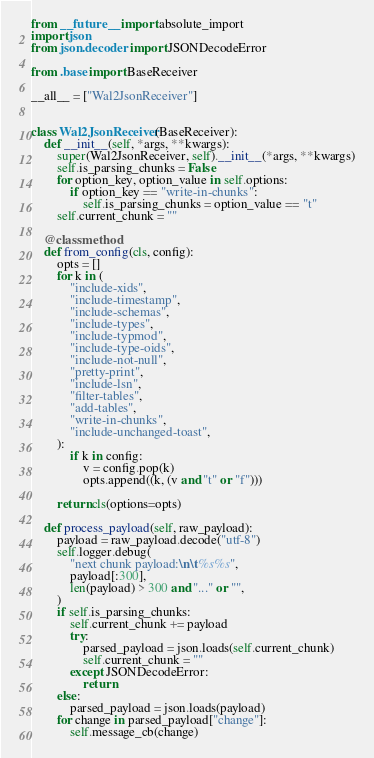Convert code to text. <code><loc_0><loc_0><loc_500><loc_500><_Python_>from __future__ import absolute_import
import json
from json.decoder import JSONDecodeError

from .base import BaseReceiver

__all__ = ["Wal2JsonReceiver"]


class Wal2JsonReceiver(BaseReceiver):
    def __init__(self, *args, **kwargs):
        super(Wal2JsonReceiver, self).__init__(*args, **kwargs)
        self.is_parsing_chunks = False
        for option_key, option_value in self.options:
            if option_key == "write-in-chunks":
                self.is_parsing_chunks = option_value == "t"
        self.current_chunk = ""

    @classmethod
    def from_config(cls, config):
        opts = []
        for k in (
            "include-xids",
            "include-timestamp",
            "include-schemas",
            "include-types",
            "include-typmod",
            "include-type-oids",
            "include-not-null",
            "pretty-print",
            "include-lsn",
            "filter-tables",
            "add-tables",
            "write-in-chunks",
            "include-unchanged-toast",
        ):
            if k in config:
                v = config.pop(k)
                opts.append((k, (v and "t" or "f")))

        return cls(options=opts)

    def process_payload(self, raw_payload):
        payload = raw_payload.decode("utf-8")
        self.logger.debug(
            "next chunk payload:\n\t%s%s",
            payload[:300],
            len(payload) > 300 and "..." or "",
        )
        if self.is_parsing_chunks:
            self.current_chunk += payload
            try:
                parsed_payload = json.loads(self.current_chunk)
                self.current_chunk = ""
            except JSONDecodeError:
                return
        else:
            parsed_payload = json.loads(payload)
        for change in parsed_payload["change"]:
            self.message_cb(change)
</code> 